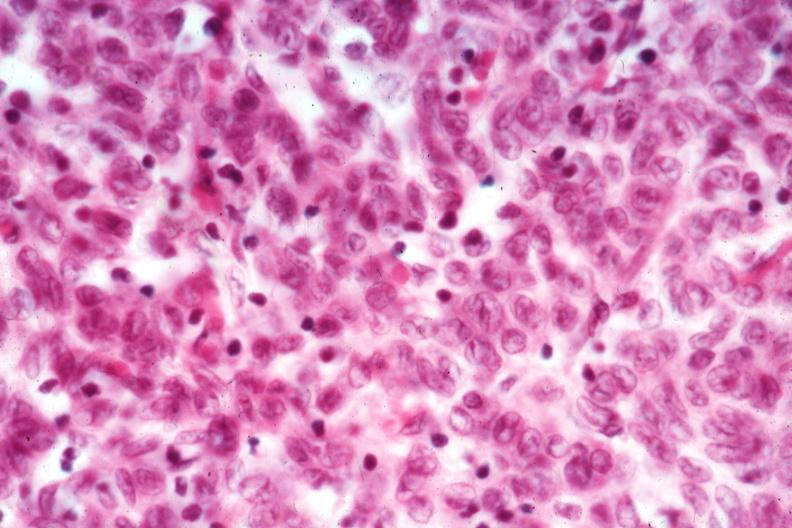what is present?
Answer the question using a single word or phrase. Hematologic 